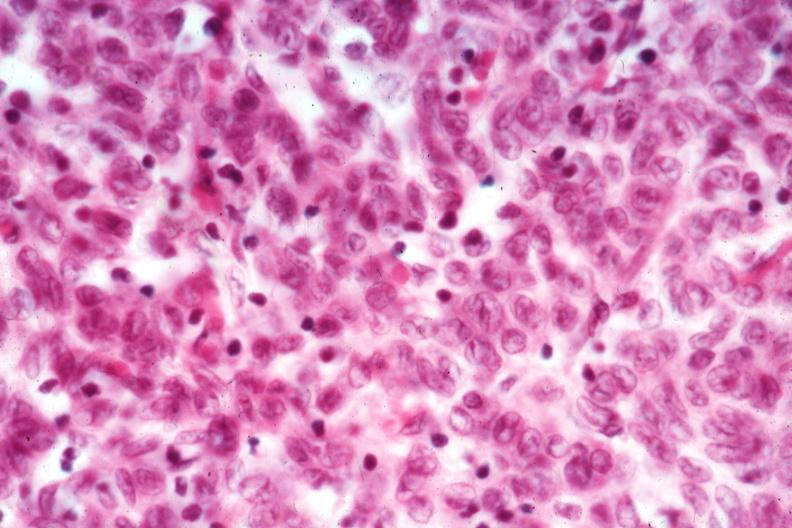what is present?
Answer the question using a single word or phrase. Hematologic 